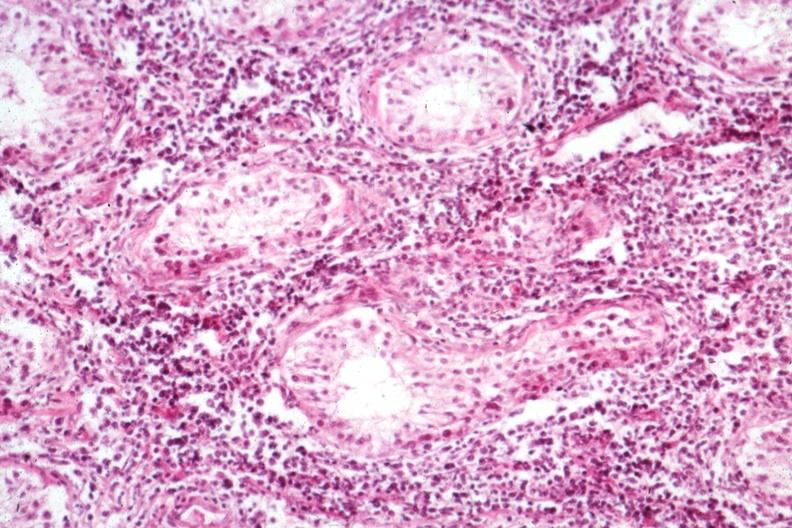s testicle present?
Answer the question using a single word or phrase. Yes 